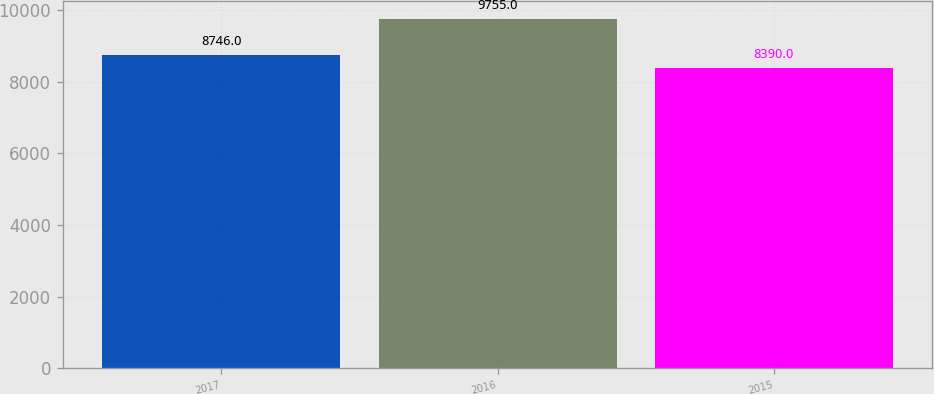Convert chart to OTSL. <chart><loc_0><loc_0><loc_500><loc_500><bar_chart><fcel>2017<fcel>2016<fcel>2015<nl><fcel>8746<fcel>9755<fcel>8390<nl></chart> 